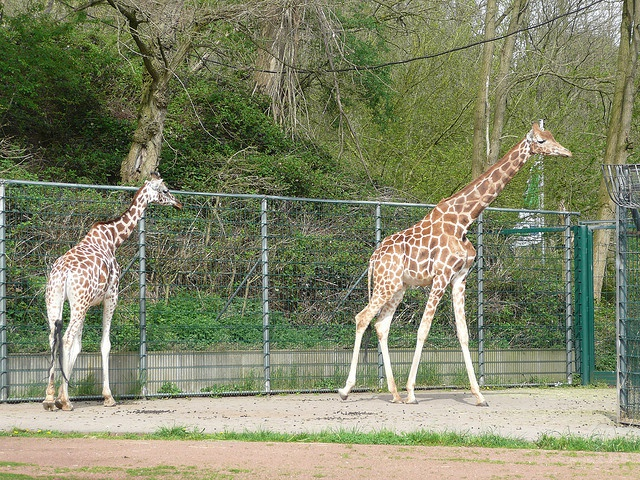Describe the objects in this image and their specific colors. I can see giraffe in gray, ivory, and tan tones and giraffe in gray, ivory, and darkgray tones in this image. 